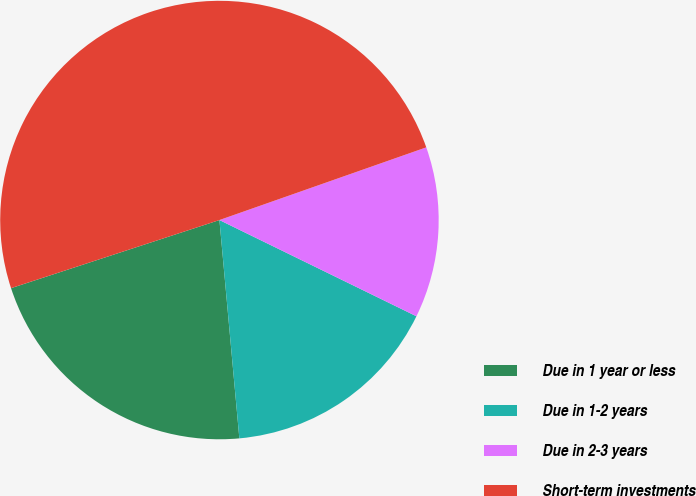Convert chart. <chart><loc_0><loc_0><loc_500><loc_500><pie_chart><fcel>Due in 1 year or less<fcel>Due in 1-2 years<fcel>Due in 2-3 years<fcel>Short-term investments<nl><fcel>21.42%<fcel>16.32%<fcel>12.61%<fcel>49.65%<nl></chart> 